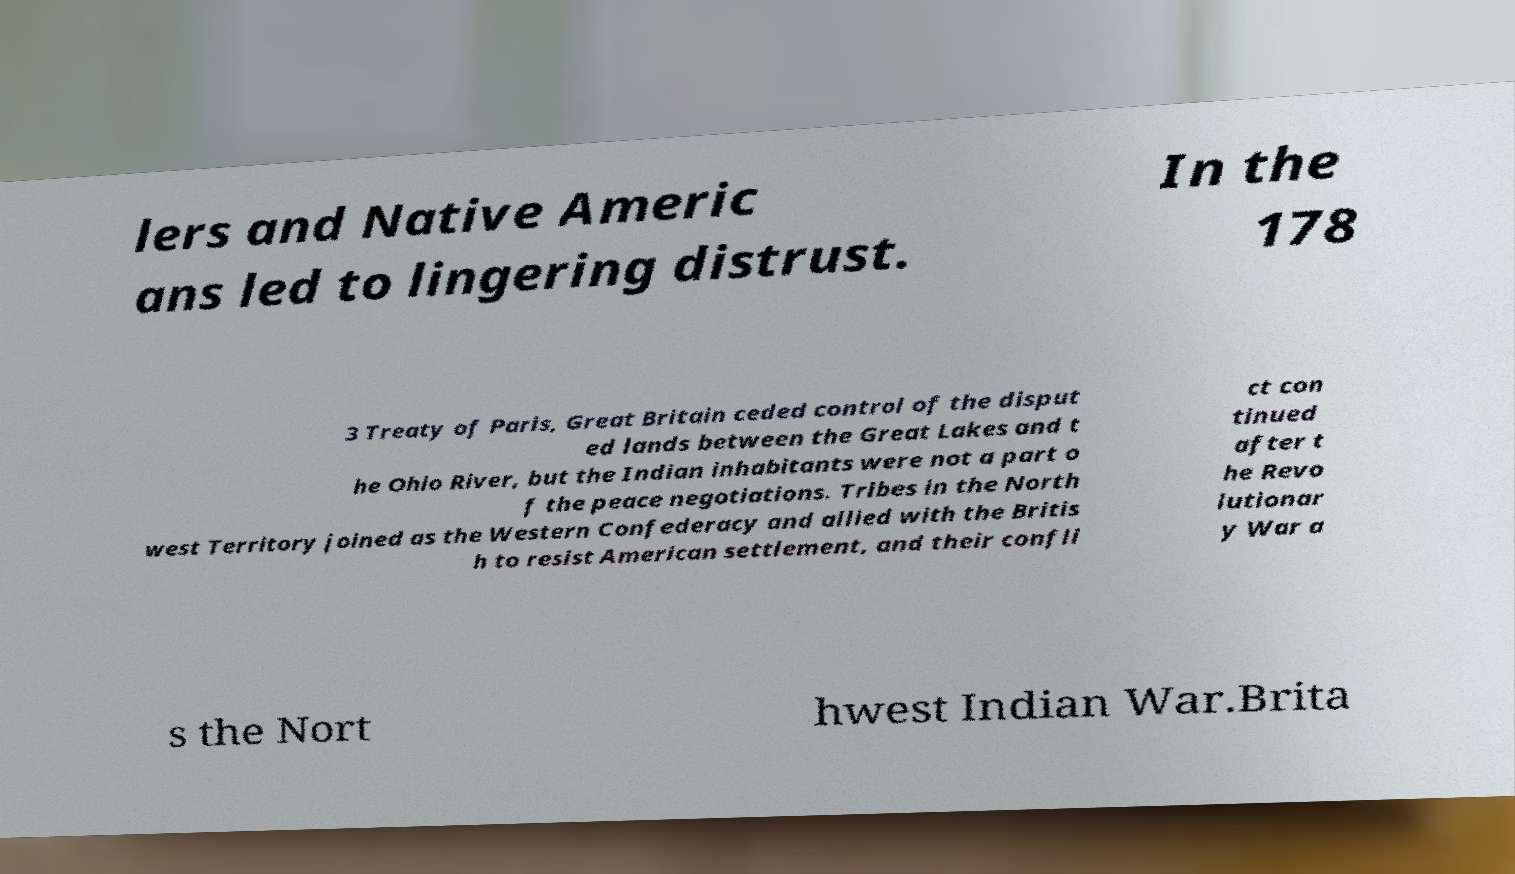For documentation purposes, I need the text within this image transcribed. Could you provide that? lers and Native Americ ans led to lingering distrust. In the 178 3 Treaty of Paris, Great Britain ceded control of the disput ed lands between the Great Lakes and t he Ohio River, but the Indian inhabitants were not a part o f the peace negotiations. Tribes in the North west Territory joined as the Western Confederacy and allied with the Britis h to resist American settlement, and their confli ct con tinued after t he Revo lutionar y War a s the Nort hwest Indian War.Brita 